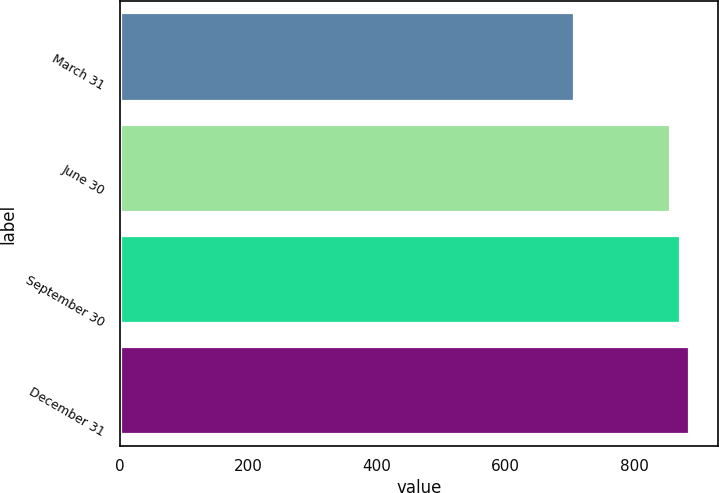Convert chart. <chart><loc_0><loc_0><loc_500><loc_500><bar_chart><fcel>March 31<fcel>June 30<fcel>September 30<fcel>December 31<nl><fcel>707<fcel>856<fcel>871<fcel>886<nl></chart> 